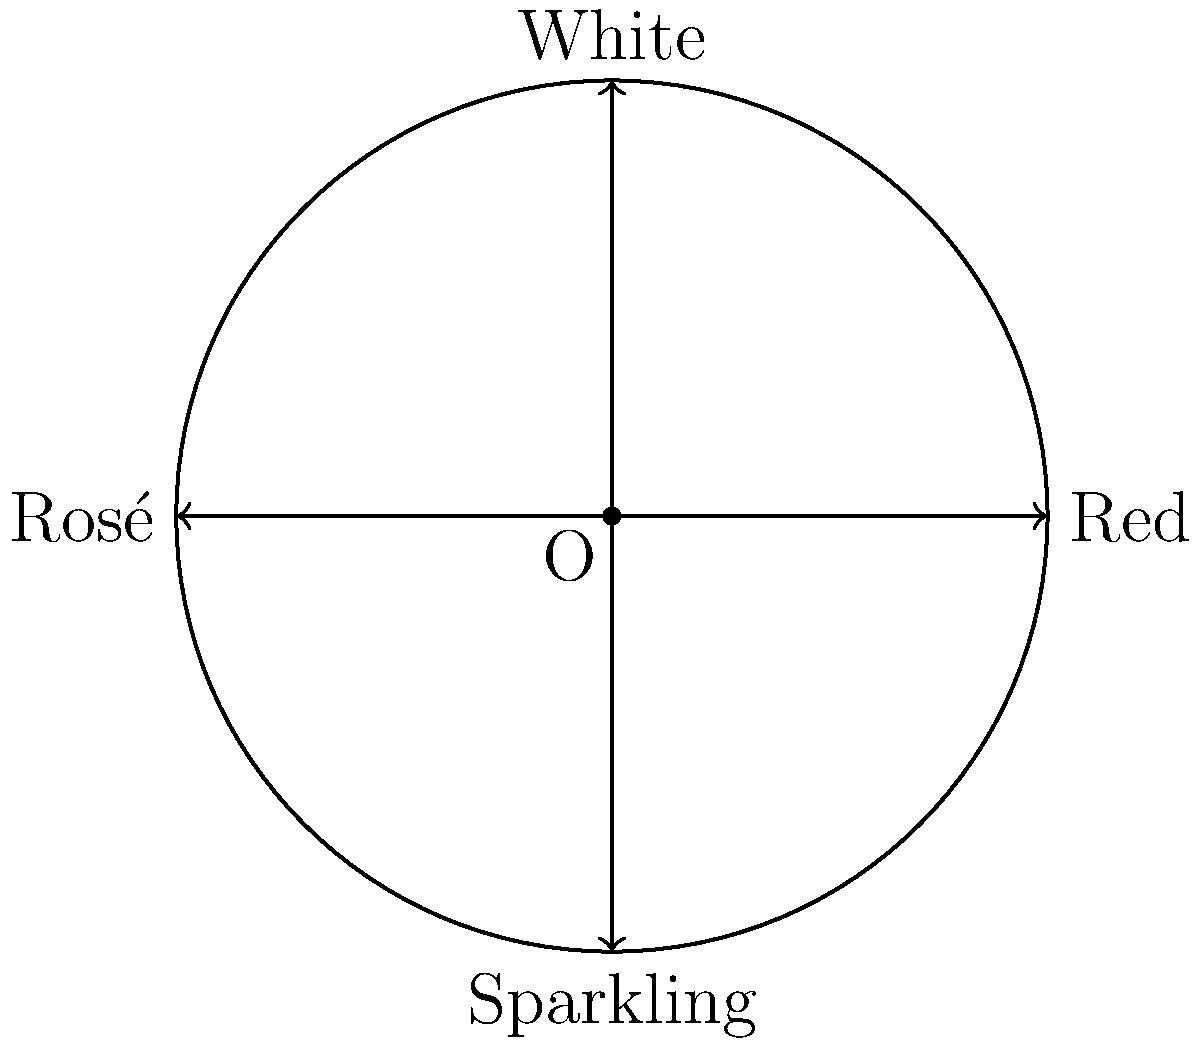A circular bar tray is divided into four equal sections, each containing a different type of wine: Red, White, Rosé, and Sparkling, as shown in the diagram. The tray can be rotated by multiples of 90°. How many different arrangements of the wines can be created through these rotations, including the original arrangement? To solve this problem, we can use the concept of cyclic groups in group theory. Let's approach this step-by-step:

1) First, we need to understand what constitutes a unique arrangement. A unique arrangement is any configuration of the wines that looks different from the others, regardless of the actual rotation applied.

2) The rotations we can apply are multiples of 90°. This means we have four possible rotations:
   - 0° (original position)
   - 90° clockwise
   - 180° clockwise
   - 270° clockwise (or 90° counterclockwise)

3) Let's see what happens with each rotation:
   - 0°: Red-White-Rosé-Sparkling (original)
   - 90°: Sparkling-Red-White-Rosé
   - 180°: Rosé-Sparkling-Red-White
   - 270°: White-Rosé-Sparkling-Red

4) We can see that each rotation produces a unique arrangement. No two arrangements are the same.

5) After a 360° rotation (or 4 steps of 90°), we return to the original arrangement.

6) This forms a cyclic group of order 4, which is isomorphic to the group $C_4$ or $\mathbb{Z}_4$.

7) The number of unique elements in this group (which corresponds to the number of unique arrangements) is equal to the order of the group, which is 4.

Therefore, there are 4 different arrangements that can be created through these rotations, including the original arrangement.
Answer: 4 